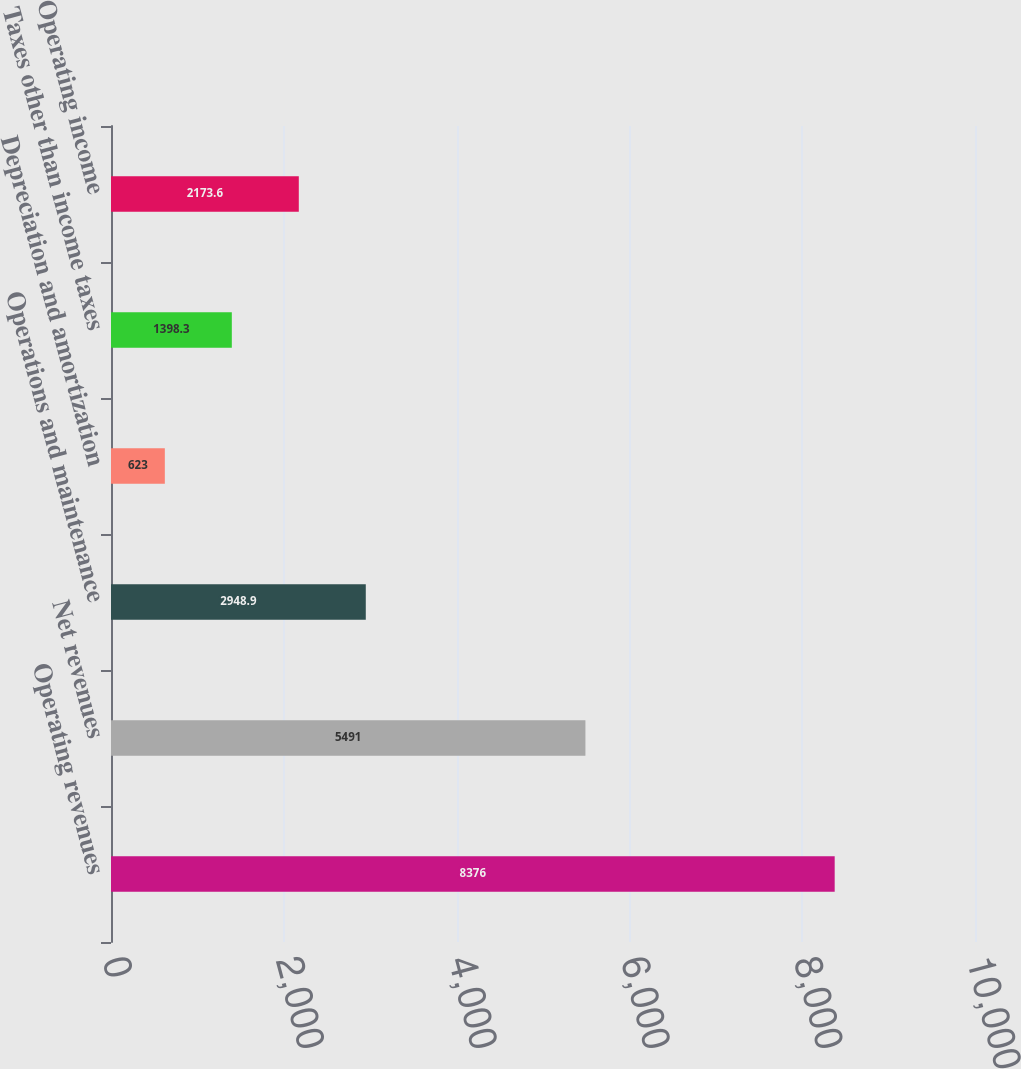Convert chart. <chart><loc_0><loc_0><loc_500><loc_500><bar_chart><fcel>Operating revenues<fcel>Net revenues<fcel>Operations and maintenance<fcel>Depreciation and amortization<fcel>Taxes other than income taxes<fcel>Operating income<nl><fcel>8376<fcel>5491<fcel>2948.9<fcel>623<fcel>1398.3<fcel>2173.6<nl></chart> 